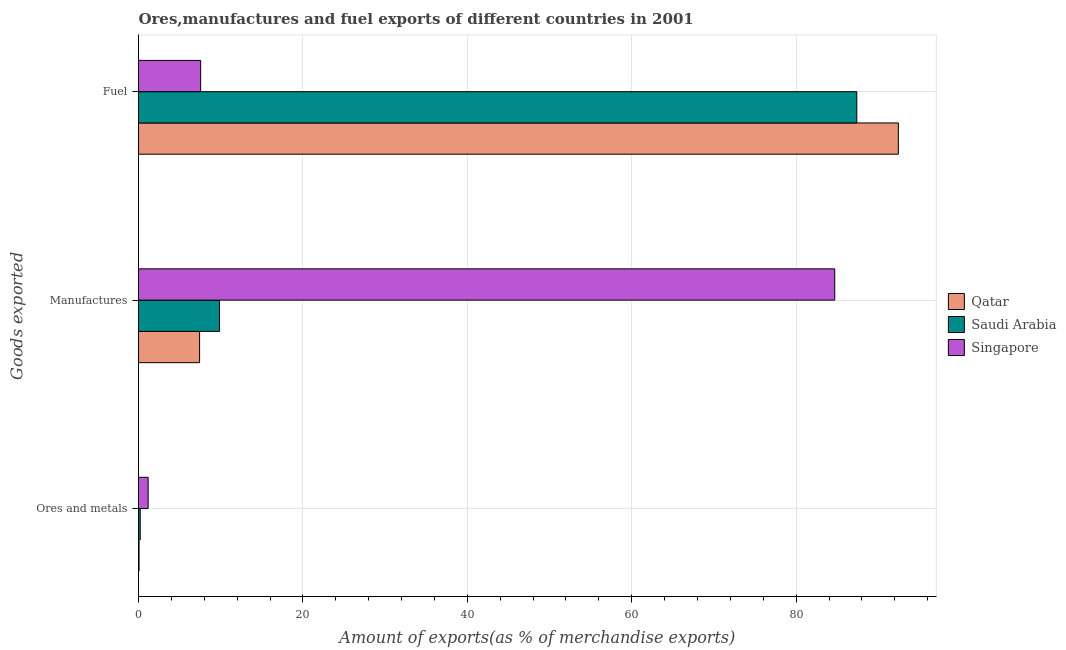How many different coloured bars are there?
Give a very brief answer. 3. Are the number of bars per tick equal to the number of legend labels?
Ensure brevity in your answer.  Yes. Are the number of bars on each tick of the Y-axis equal?
Keep it short and to the point. Yes. What is the label of the 3rd group of bars from the top?
Ensure brevity in your answer.  Ores and metals. What is the percentage of manufactures exports in Saudi Arabia?
Ensure brevity in your answer.  9.86. Across all countries, what is the maximum percentage of ores and metals exports?
Your answer should be compact. 1.17. Across all countries, what is the minimum percentage of fuel exports?
Provide a succinct answer. 7.56. In which country was the percentage of ores and metals exports maximum?
Make the answer very short. Singapore. In which country was the percentage of ores and metals exports minimum?
Offer a very short reply. Qatar. What is the total percentage of fuel exports in the graph?
Make the answer very short. 187.37. What is the difference between the percentage of fuel exports in Singapore and that in Qatar?
Provide a short and direct response. -84.87. What is the difference between the percentage of manufactures exports in Singapore and the percentage of ores and metals exports in Qatar?
Your answer should be very brief. 84.63. What is the average percentage of manufactures exports per country?
Your response must be concise. 33.99. What is the difference between the percentage of ores and metals exports and percentage of manufactures exports in Singapore?
Make the answer very short. -83.52. In how many countries, is the percentage of manufactures exports greater than 24 %?
Your response must be concise. 1. What is the ratio of the percentage of fuel exports in Qatar to that in Saudi Arabia?
Provide a short and direct response. 1.06. Is the difference between the percentage of ores and metals exports in Singapore and Qatar greater than the difference between the percentage of fuel exports in Singapore and Qatar?
Provide a succinct answer. Yes. What is the difference between the highest and the second highest percentage of fuel exports?
Offer a terse response. 5.05. What is the difference between the highest and the lowest percentage of ores and metals exports?
Keep it short and to the point. 1.11. In how many countries, is the percentage of manufactures exports greater than the average percentage of manufactures exports taken over all countries?
Give a very brief answer. 1. Is the sum of the percentage of manufactures exports in Singapore and Saudi Arabia greater than the maximum percentage of fuel exports across all countries?
Provide a short and direct response. Yes. What does the 1st bar from the top in Fuel represents?
Offer a terse response. Singapore. What does the 3rd bar from the bottom in Fuel represents?
Your answer should be very brief. Singapore. How many bars are there?
Offer a very short reply. 9. Are all the bars in the graph horizontal?
Provide a short and direct response. Yes. What is the difference between two consecutive major ticks on the X-axis?
Offer a terse response. 20. What is the title of the graph?
Ensure brevity in your answer.  Ores,manufactures and fuel exports of different countries in 2001. Does "Lithuania" appear as one of the legend labels in the graph?
Offer a very short reply. No. What is the label or title of the X-axis?
Provide a succinct answer. Amount of exports(as % of merchandise exports). What is the label or title of the Y-axis?
Provide a succinct answer. Goods exported. What is the Amount of exports(as % of merchandise exports) in Qatar in Ores and metals?
Offer a terse response. 0.07. What is the Amount of exports(as % of merchandise exports) of Saudi Arabia in Ores and metals?
Offer a very short reply. 0.21. What is the Amount of exports(as % of merchandise exports) in Singapore in Ores and metals?
Make the answer very short. 1.17. What is the Amount of exports(as % of merchandise exports) of Qatar in Manufactures?
Give a very brief answer. 7.43. What is the Amount of exports(as % of merchandise exports) of Saudi Arabia in Manufactures?
Provide a succinct answer. 9.86. What is the Amount of exports(as % of merchandise exports) in Singapore in Manufactures?
Your response must be concise. 84.69. What is the Amount of exports(as % of merchandise exports) of Qatar in Fuel?
Your answer should be compact. 92.43. What is the Amount of exports(as % of merchandise exports) of Saudi Arabia in Fuel?
Give a very brief answer. 87.38. What is the Amount of exports(as % of merchandise exports) of Singapore in Fuel?
Give a very brief answer. 7.56. Across all Goods exported, what is the maximum Amount of exports(as % of merchandise exports) in Qatar?
Give a very brief answer. 92.43. Across all Goods exported, what is the maximum Amount of exports(as % of merchandise exports) of Saudi Arabia?
Your answer should be very brief. 87.38. Across all Goods exported, what is the maximum Amount of exports(as % of merchandise exports) of Singapore?
Offer a terse response. 84.69. Across all Goods exported, what is the minimum Amount of exports(as % of merchandise exports) of Qatar?
Offer a very short reply. 0.07. Across all Goods exported, what is the minimum Amount of exports(as % of merchandise exports) of Saudi Arabia?
Your answer should be compact. 0.21. Across all Goods exported, what is the minimum Amount of exports(as % of merchandise exports) in Singapore?
Your answer should be very brief. 1.17. What is the total Amount of exports(as % of merchandise exports) in Qatar in the graph?
Give a very brief answer. 99.93. What is the total Amount of exports(as % of merchandise exports) in Saudi Arabia in the graph?
Your answer should be very brief. 97.44. What is the total Amount of exports(as % of merchandise exports) in Singapore in the graph?
Ensure brevity in your answer.  93.42. What is the difference between the Amount of exports(as % of merchandise exports) of Qatar in Ores and metals and that in Manufactures?
Your answer should be very brief. -7.37. What is the difference between the Amount of exports(as % of merchandise exports) of Saudi Arabia in Ores and metals and that in Manufactures?
Keep it short and to the point. -9.65. What is the difference between the Amount of exports(as % of merchandise exports) in Singapore in Ores and metals and that in Manufactures?
Provide a short and direct response. -83.52. What is the difference between the Amount of exports(as % of merchandise exports) in Qatar in Ores and metals and that in Fuel?
Provide a short and direct response. -92.36. What is the difference between the Amount of exports(as % of merchandise exports) of Saudi Arabia in Ores and metals and that in Fuel?
Offer a very short reply. -87.17. What is the difference between the Amount of exports(as % of merchandise exports) in Singapore in Ores and metals and that in Fuel?
Give a very brief answer. -6.39. What is the difference between the Amount of exports(as % of merchandise exports) of Qatar in Manufactures and that in Fuel?
Offer a terse response. -85. What is the difference between the Amount of exports(as % of merchandise exports) of Saudi Arabia in Manufactures and that in Fuel?
Provide a short and direct response. -77.52. What is the difference between the Amount of exports(as % of merchandise exports) of Singapore in Manufactures and that in Fuel?
Your answer should be very brief. 77.13. What is the difference between the Amount of exports(as % of merchandise exports) in Qatar in Ores and metals and the Amount of exports(as % of merchandise exports) in Saudi Arabia in Manufactures?
Make the answer very short. -9.79. What is the difference between the Amount of exports(as % of merchandise exports) of Qatar in Ores and metals and the Amount of exports(as % of merchandise exports) of Singapore in Manufactures?
Offer a terse response. -84.63. What is the difference between the Amount of exports(as % of merchandise exports) in Saudi Arabia in Ores and metals and the Amount of exports(as % of merchandise exports) in Singapore in Manufactures?
Your answer should be compact. -84.48. What is the difference between the Amount of exports(as % of merchandise exports) of Qatar in Ores and metals and the Amount of exports(as % of merchandise exports) of Saudi Arabia in Fuel?
Keep it short and to the point. -87.31. What is the difference between the Amount of exports(as % of merchandise exports) of Qatar in Ores and metals and the Amount of exports(as % of merchandise exports) of Singapore in Fuel?
Offer a very short reply. -7.49. What is the difference between the Amount of exports(as % of merchandise exports) of Saudi Arabia in Ores and metals and the Amount of exports(as % of merchandise exports) of Singapore in Fuel?
Make the answer very short. -7.35. What is the difference between the Amount of exports(as % of merchandise exports) of Qatar in Manufactures and the Amount of exports(as % of merchandise exports) of Saudi Arabia in Fuel?
Offer a terse response. -79.94. What is the difference between the Amount of exports(as % of merchandise exports) of Qatar in Manufactures and the Amount of exports(as % of merchandise exports) of Singapore in Fuel?
Your answer should be compact. -0.13. What is the difference between the Amount of exports(as % of merchandise exports) of Saudi Arabia in Manufactures and the Amount of exports(as % of merchandise exports) of Singapore in Fuel?
Your answer should be compact. 2.3. What is the average Amount of exports(as % of merchandise exports) in Qatar per Goods exported?
Ensure brevity in your answer.  33.31. What is the average Amount of exports(as % of merchandise exports) in Saudi Arabia per Goods exported?
Provide a short and direct response. 32.48. What is the average Amount of exports(as % of merchandise exports) in Singapore per Goods exported?
Give a very brief answer. 31.14. What is the difference between the Amount of exports(as % of merchandise exports) of Qatar and Amount of exports(as % of merchandise exports) of Saudi Arabia in Ores and metals?
Ensure brevity in your answer.  -0.14. What is the difference between the Amount of exports(as % of merchandise exports) in Qatar and Amount of exports(as % of merchandise exports) in Singapore in Ores and metals?
Offer a very short reply. -1.11. What is the difference between the Amount of exports(as % of merchandise exports) in Saudi Arabia and Amount of exports(as % of merchandise exports) in Singapore in Ores and metals?
Your answer should be very brief. -0.96. What is the difference between the Amount of exports(as % of merchandise exports) of Qatar and Amount of exports(as % of merchandise exports) of Saudi Arabia in Manufactures?
Make the answer very short. -2.43. What is the difference between the Amount of exports(as % of merchandise exports) of Qatar and Amount of exports(as % of merchandise exports) of Singapore in Manufactures?
Your response must be concise. -77.26. What is the difference between the Amount of exports(as % of merchandise exports) of Saudi Arabia and Amount of exports(as % of merchandise exports) of Singapore in Manufactures?
Offer a very short reply. -74.84. What is the difference between the Amount of exports(as % of merchandise exports) in Qatar and Amount of exports(as % of merchandise exports) in Saudi Arabia in Fuel?
Provide a succinct answer. 5.05. What is the difference between the Amount of exports(as % of merchandise exports) in Qatar and Amount of exports(as % of merchandise exports) in Singapore in Fuel?
Make the answer very short. 84.87. What is the difference between the Amount of exports(as % of merchandise exports) of Saudi Arabia and Amount of exports(as % of merchandise exports) of Singapore in Fuel?
Your answer should be very brief. 79.82. What is the ratio of the Amount of exports(as % of merchandise exports) in Qatar in Ores and metals to that in Manufactures?
Offer a very short reply. 0.01. What is the ratio of the Amount of exports(as % of merchandise exports) of Saudi Arabia in Ores and metals to that in Manufactures?
Ensure brevity in your answer.  0.02. What is the ratio of the Amount of exports(as % of merchandise exports) in Singapore in Ores and metals to that in Manufactures?
Give a very brief answer. 0.01. What is the ratio of the Amount of exports(as % of merchandise exports) of Qatar in Ores and metals to that in Fuel?
Your response must be concise. 0. What is the ratio of the Amount of exports(as % of merchandise exports) of Saudi Arabia in Ores and metals to that in Fuel?
Keep it short and to the point. 0. What is the ratio of the Amount of exports(as % of merchandise exports) in Singapore in Ores and metals to that in Fuel?
Your response must be concise. 0.16. What is the ratio of the Amount of exports(as % of merchandise exports) in Qatar in Manufactures to that in Fuel?
Your response must be concise. 0.08. What is the ratio of the Amount of exports(as % of merchandise exports) in Saudi Arabia in Manufactures to that in Fuel?
Your response must be concise. 0.11. What is the ratio of the Amount of exports(as % of merchandise exports) in Singapore in Manufactures to that in Fuel?
Keep it short and to the point. 11.2. What is the difference between the highest and the second highest Amount of exports(as % of merchandise exports) of Qatar?
Your answer should be very brief. 85. What is the difference between the highest and the second highest Amount of exports(as % of merchandise exports) in Saudi Arabia?
Keep it short and to the point. 77.52. What is the difference between the highest and the second highest Amount of exports(as % of merchandise exports) in Singapore?
Offer a terse response. 77.13. What is the difference between the highest and the lowest Amount of exports(as % of merchandise exports) in Qatar?
Offer a terse response. 92.36. What is the difference between the highest and the lowest Amount of exports(as % of merchandise exports) in Saudi Arabia?
Ensure brevity in your answer.  87.17. What is the difference between the highest and the lowest Amount of exports(as % of merchandise exports) in Singapore?
Offer a very short reply. 83.52. 